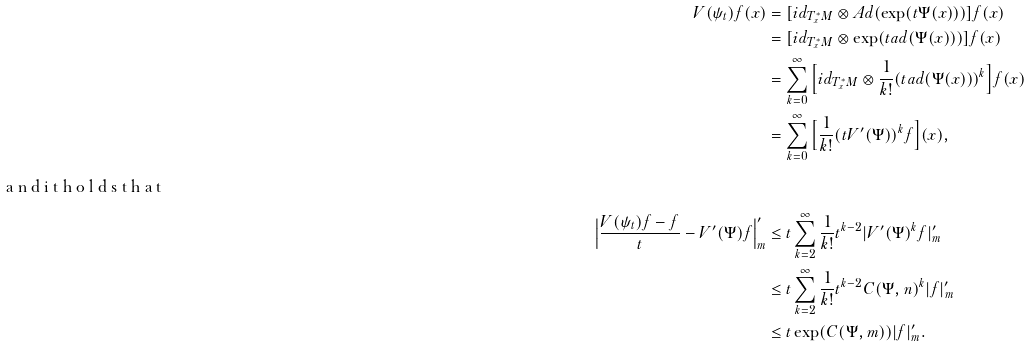Convert formula to latex. <formula><loc_0><loc_0><loc_500><loc_500>V ( \psi _ { t } ) f ( x ) & = [ i d _ { T ^ { * } _ { x } M } \otimes A d ( \exp ( t \Psi ( x ) ) ) ] f ( x ) \\ & = [ i d _ { T ^ { * } _ { x } M } \otimes \exp ( t a d ( \Psi ( x ) ) ) ] f ( x ) \\ & = \sum _ { k = 0 } ^ { \infty } \Big { [ } i d _ { T ^ { * } _ { x } M } \otimes \frac { 1 } { k ! } ( t a d ( \Psi ( x ) ) ) ^ { k } \Big { ] } f ( x ) \\ & = \sum _ { k = 0 } ^ { \infty } \Big { [ } \frac { 1 } { k ! } ( t V ^ { \prime } ( \Psi ) ) ^ { k } f \Big { ] } ( x ) , \\ \intertext { a n d i t h o l d s t h a t } \Big { | } \frac { V ( \psi _ { t } ) f - f } { t } - V ^ { \prime } ( \Psi ) f \Big { | } ^ { \prime } _ { m } & \leq t \sum _ { k = 2 } ^ { \infty } \frac { 1 } { k ! } t ^ { k - 2 } | V ^ { \prime } ( \Psi ) ^ { k } f | ^ { \prime } _ { m } \\ & \leq t \sum _ { k = 2 } ^ { \infty } \frac { 1 } { k ! } t ^ { k - 2 } C ( \Psi , n ) ^ { k } | f | ^ { \prime } _ { m } \\ & \leq t \exp ( C ( \Psi , m ) ) | f | ^ { \prime } _ { m } . \\</formula> 